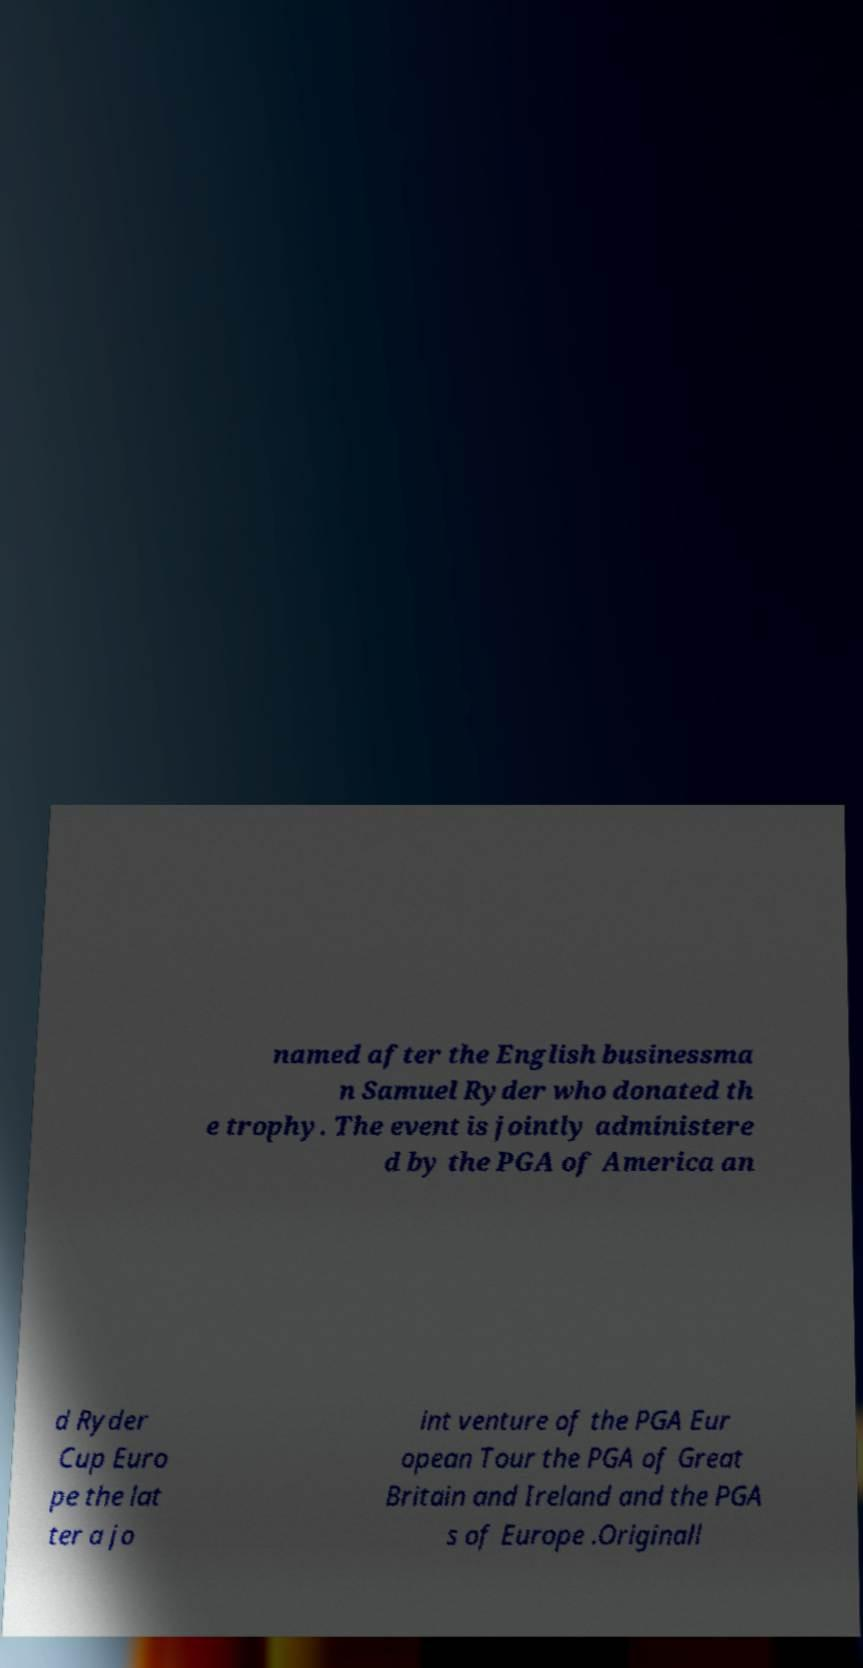What messages or text are displayed in this image? I need them in a readable, typed format. named after the English businessma n Samuel Ryder who donated th e trophy. The event is jointly administere d by the PGA of America an d Ryder Cup Euro pe the lat ter a jo int venture of the PGA Eur opean Tour the PGA of Great Britain and Ireland and the PGA s of Europe .Originall 